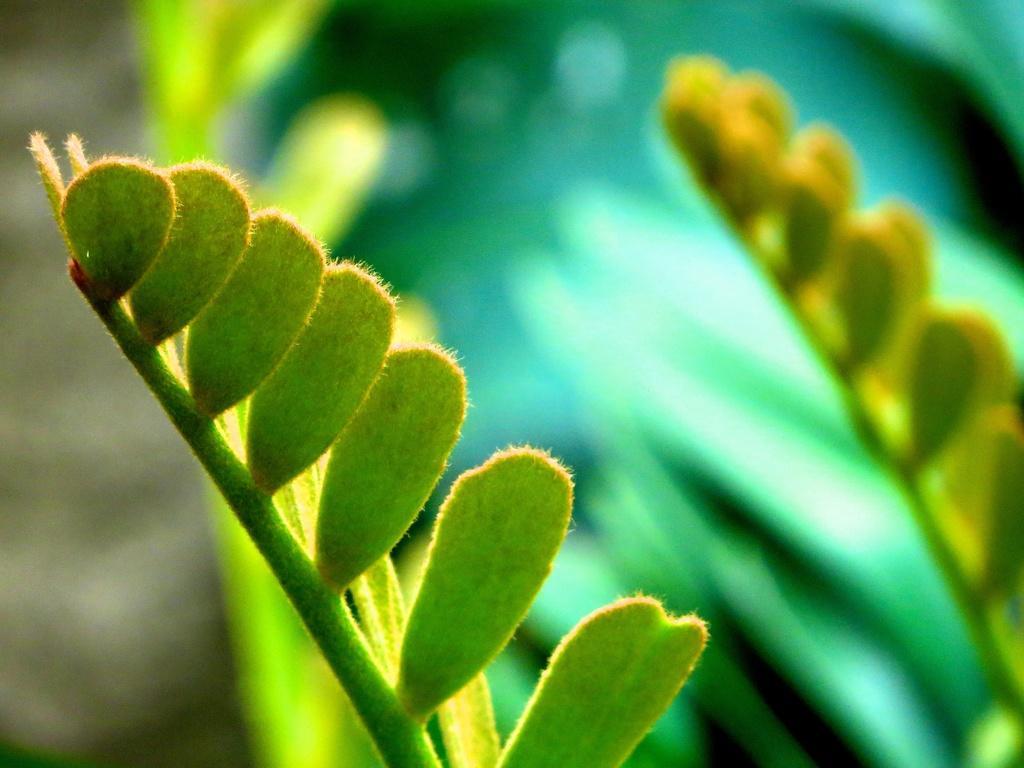In one or two sentences, can you explain what this image depicts? This image is taken outdoors. In this image the background is a little blurred. In the middle of the image there is a plant with green leaves. 